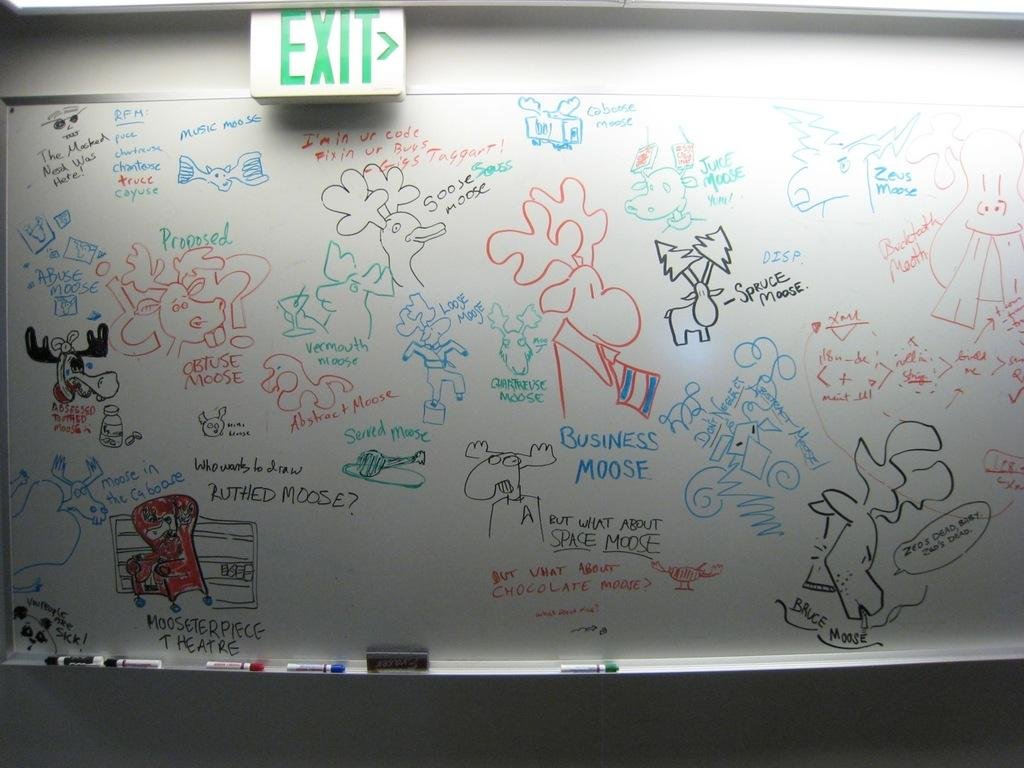<image>
Create a compact narrative representing the image presented. A white board full of different drawings with names that rhyme with moose, like "Juice Moose", "Abuse Moose", "Spruce Moose". 